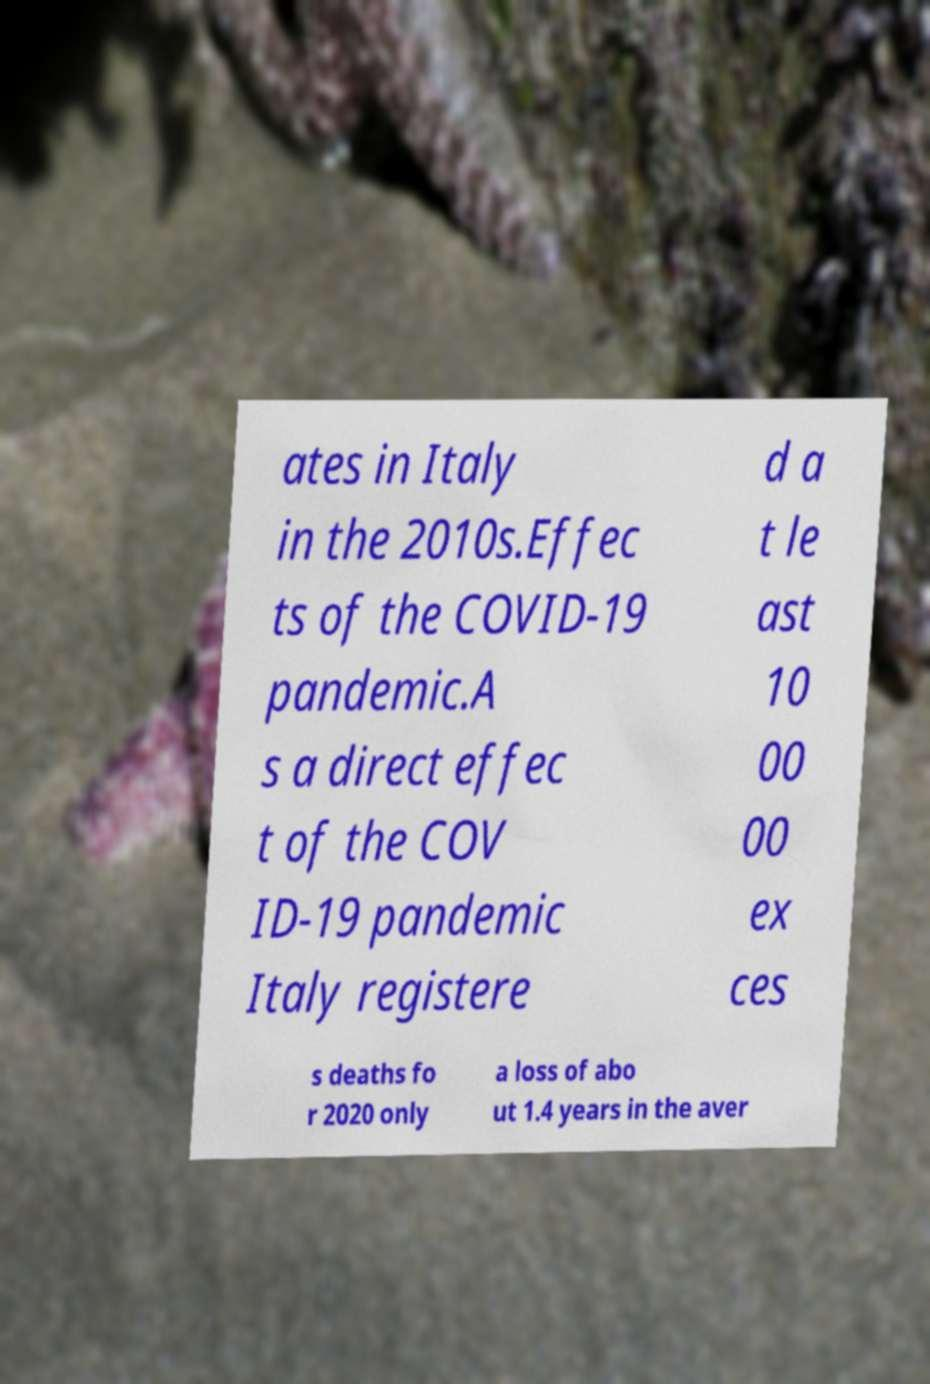Could you extract and type out the text from this image? ates in Italy in the 2010s.Effec ts of the COVID-19 pandemic.A s a direct effec t of the COV ID-19 pandemic Italy registere d a t le ast 10 00 00 ex ces s deaths fo r 2020 only a loss of abo ut 1.4 years in the aver 